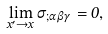<formula> <loc_0><loc_0><loc_500><loc_500>\lim _ { x ^ { \prime } \to x } { \sigma } _ { ; { \alpha } { \beta } { \gamma } } = 0 ,</formula> 